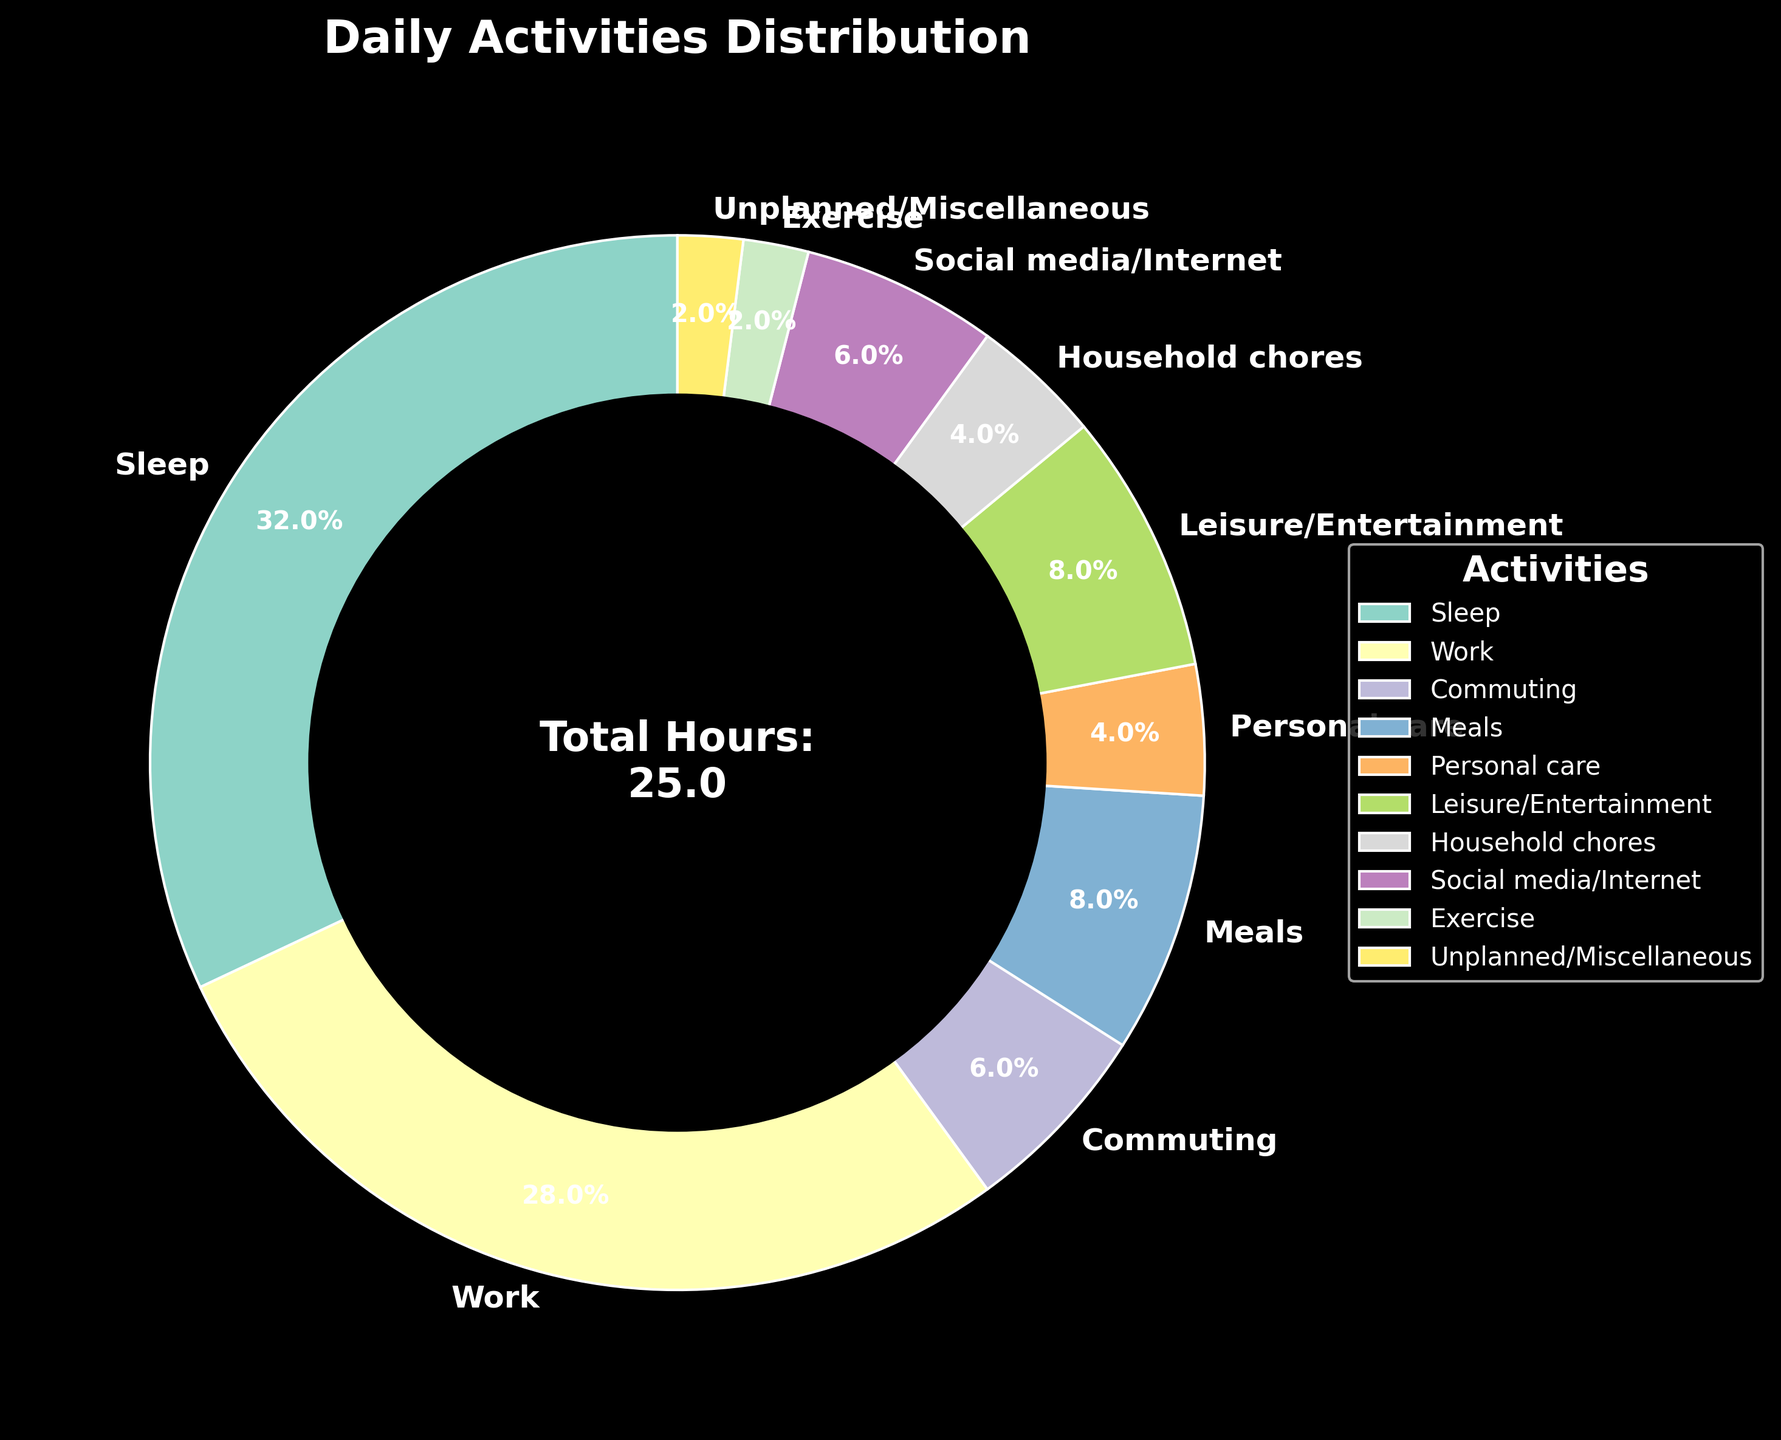What's the activity that takes up the most time? By looking at the pie chart, you can see that the largest portion is allocated to "Sleep".
Answer: Sleep Which activity takes the least amount of time? The smallest wedge in the pie chart represents "Exercise" and "Unplanned/Miscellaneous", indicating these activities take up the least amount of time.
Answer: Exercise and Unplanned/Miscellaneous How much time is spent on work and commuting combined? Add the hours for "Work" (7) and "Commuting" (1.5). 7 + 1.5 = 8.5 hours.
Answer: 8.5 hours Is more time spent on leisure/entertainment or social media/internet? Comparing the sizes of the wedges, "Leisure/Entertainment" is 2 hours while "Social media/Internet" is 1.5 hours.
Answer: Leisure/Entertainment What's the difference in time spent between household chores and meals? Subtract the hours spent on "Household chores" (1) from "Meals" (2). 2 - 1 = 1 hour.
Answer: 1 hour Which activity is given more time: exercise or personal care? The pie chart shows "Personal care" has 1 hour, whereas "Exercise" has 0.5 hours.
Answer: Personal care What percentage of the day is spent on sleep and work combined? Calculate the combined hours for "Sleep" (8) and "Work" (7), then find the percentage: (8 + 7) / 24 * 100. (15 / 24) * 100 ≈ 62.5%.
Answer: 62.5% Are more hours spent on meals than on commuting and household chores combined? Compare the hours for "Meals" (2) with the combined hours for "Commuting" (1.5) and "Household chores" (1). 2 <= (1.5 + 1)
Answer: No What's the average time spent on all activities? Sum all the hours and divide by the number of activities. (8 + 7 + 1.5 + 2 + 1 + 2 + 1 + 1.5 + 0.5 + 0.5) / 10. Total is 25 hours, so 25 / 10 = 2.5 hours per activity.
Answer: 2.5 hours What's the total time spent on non-work activities? Total hours in a day (24) minus hours spent on "Work" (7). 24 - 7 = 17 hours.
Answer: 17 hours 